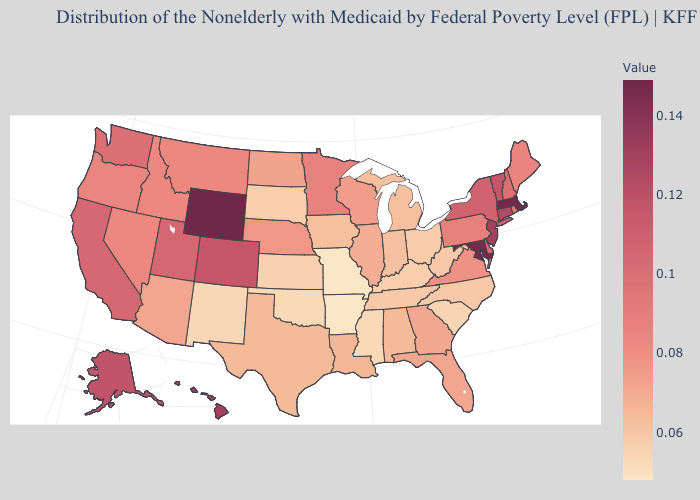Which states have the lowest value in the West?
Be succinct. New Mexico. Which states have the highest value in the USA?
Quick response, please. Wyoming. Does Idaho have a lower value than Louisiana?
Short answer required. No. 